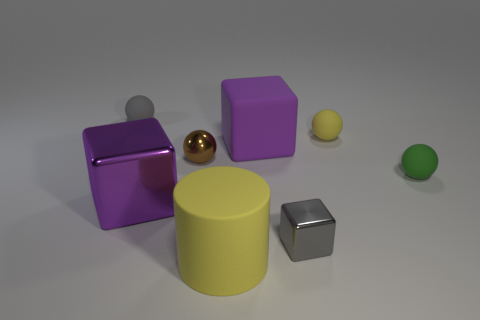Subtract 1 spheres. How many spheres are left? 3 Add 1 small gray rubber cylinders. How many objects exist? 9 Subtract all cubes. How many objects are left? 5 Subtract all brown rubber objects. Subtract all gray metal cubes. How many objects are left? 7 Add 3 green things. How many green things are left? 4 Add 4 tiny cyan matte blocks. How many tiny cyan matte blocks exist? 4 Subtract 0 purple cylinders. How many objects are left? 8 